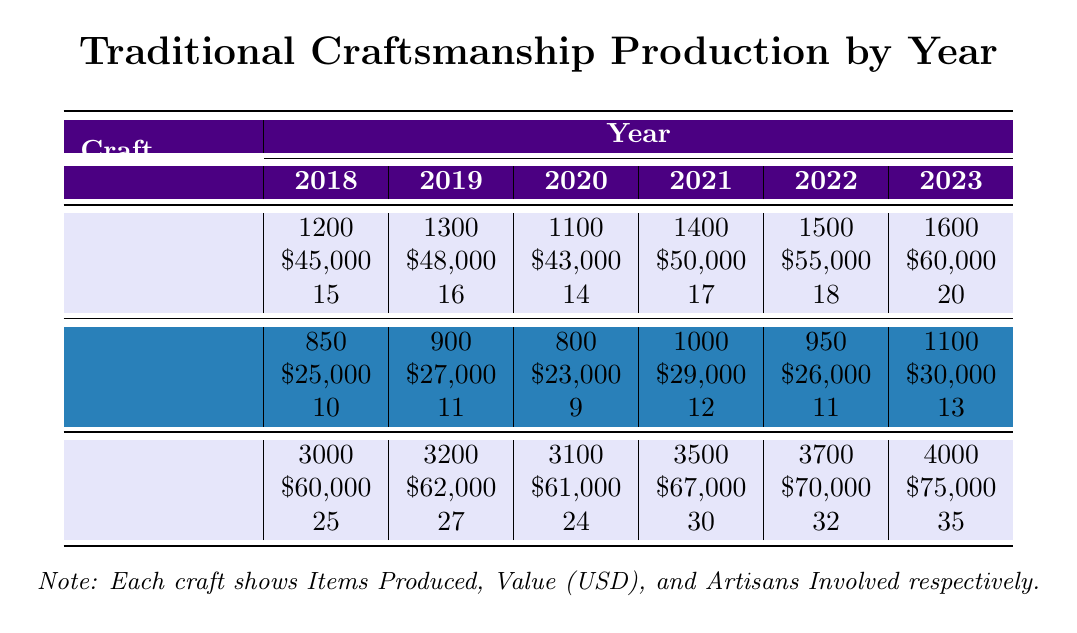What was the total number of items produced in woodworking from 2018 to 2023? To find the total, add the items produced each year: 1200 + 1300 + 1100 + 1400 + 1500 + 1600 = 8100.
Answer: 8100 Which year had the lowest value of pottery produced? The values for pottery by year are: 25000, 27000, 23000, 29000, 26000, 30000. The lowest value is 23000 in 2020.
Answer: 2020 How many artisans were involved in textiles production in 2021? According to the table, the number of artisans involved in textiles production in 2021 is 30.
Answer: 30 What is the average value of woodworking production from 2018 to 2023? First, we sum the values: 45000 + 48000 + 43000 + 50000 + 55000 + 60000 = 301000. Then, divide by the number of years (6): 301000 / 6 = 50166.67.
Answer: 50166.67 Did the production of pottery increase every year from 2018 to 2023? Checking the pottery items produced each year: 850, 900, 800, 1000, 950, 1100 shows that it decreased between 2018 and 2019, then again between 2019 and 2020, therefore it did not increase every year.
Answer: No What was the percentage increase in the number of artisans involved in textiles from 2018 to 2023? The number of artisans for textiles in 2018 was 25 and in 2023 it was 35. The increase is 35 - 25 = 10. The percentage increase is (10 / 25) * 100 = 40%.
Answer: 40% What is the highest number of items produced in any craft in any year? The highest production was in textiles in 2023 with 4000 items.
Answer: 4000 If the value of woodworking in 2022 is compared to that in 2020, what is the difference? The value of woodworking in 2022 is $55,000 and in 2020 it is $43,000. The difference is 55000 - 43000 = 12000.
Answer: 12000 Which crafts had an increase in items produced from 2022 to 2023? Examining the table: woodworking increased from 1500 to 1600, pottery from 950 to 1100, and textiles from 3700 to 4000, so all crafts had an increase.
Answer: All crafts 